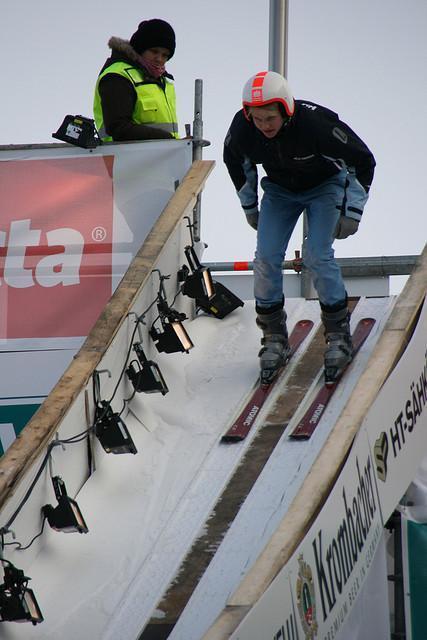How many people are in the picture?
Give a very brief answer. 2. How many blue frosted donuts can you count?
Give a very brief answer. 0. 